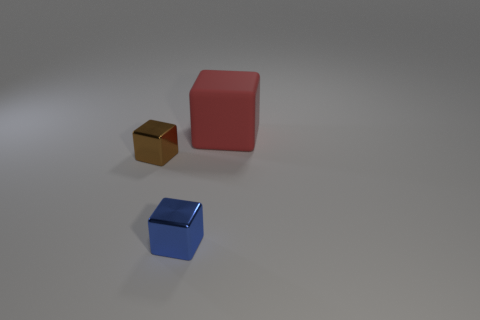Subtract all brown metal cubes. How many cubes are left? 2 Add 3 purple spheres. How many objects exist? 6 Subtract all tiny shiny cubes. Subtract all green metal things. How many objects are left? 1 Add 3 small shiny cubes. How many small shiny cubes are left? 5 Add 1 yellow rubber blocks. How many yellow rubber blocks exist? 1 Subtract 1 red blocks. How many objects are left? 2 